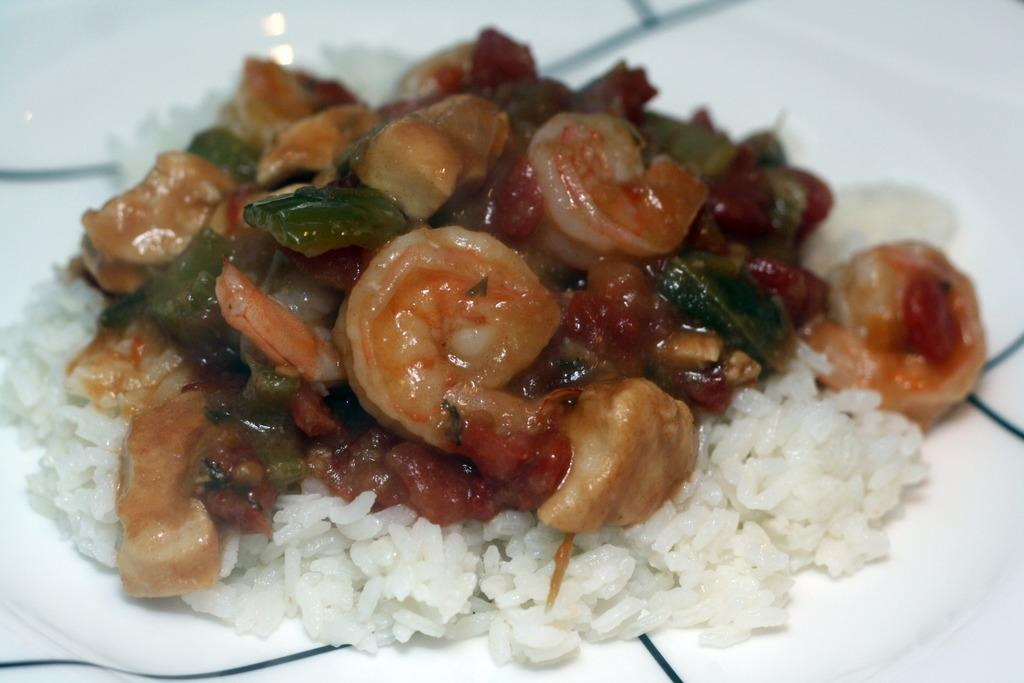What is on the plate that is visible in the image? There is food on a plate in the image. What color is the plate? The plate is white. What colors can be seen in the food on the plate? The food has white, red, and green colors. What letter is written on the plate in the image? There is no letter written on the plate in the image. Is there a bear sitting next to the plate in the image? There is no bear present in the image. 